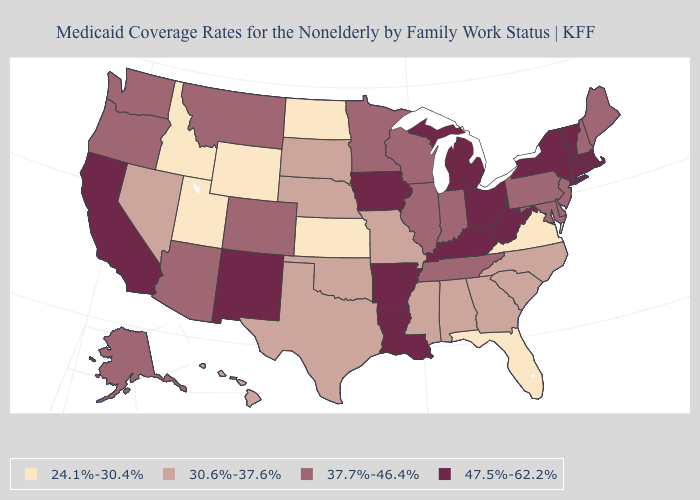How many symbols are there in the legend?
Keep it brief. 4. Name the states that have a value in the range 30.6%-37.6%?
Short answer required. Alabama, Georgia, Hawaii, Mississippi, Missouri, Nebraska, Nevada, North Carolina, Oklahoma, South Carolina, South Dakota, Texas. Name the states that have a value in the range 30.6%-37.6%?
Keep it brief. Alabama, Georgia, Hawaii, Mississippi, Missouri, Nebraska, Nevada, North Carolina, Oklahoma, South Carolina, South Dakota, Texas. What is the value of Georgia?
Keep it brief. 30.6%-37.6%. What is the value of Virginia?
Short answer required. 24.1%-30.4%. Name the states that have a value in the range 30.6%-37.6%?
Quick response, please. Alabama, Georgia, Hawaii, Mississippi, Missouri, Nebraska, Nevada, North Carolina, Oklahoma, South Carolina, South Dakota, Texas. Does New York have the highest value in the USA?
Quick response, please. Yes. What is the lowest value in states that border Utah?
Quick response, please. 24.1%-30.4%. Does Colorado have the highest value in the USA?
Short answer required. No. What is the value of Hawaii?
Give a very brief answer. 30.6%-37.6%. Does Utah have the lowest value in the USA?
Quick response, please. Yes. Does Kentucky have the lowest value in the USA?
Keep it brief. No. Does Louisiana have the same value as Illinois?
Write a very short answer. No. Name the states that have a value in the range 30.6%-37.6%?
Give a very brief answer. Alabama, Georgia, Hawaii, Mississippi, Missouri, Nebraska, Nevada, North Carolina, Oklahoma, South Carolina, South Dakota, Texas. What is the highest value in the South ?
Answer briefly. 47.5%-62.2%. 